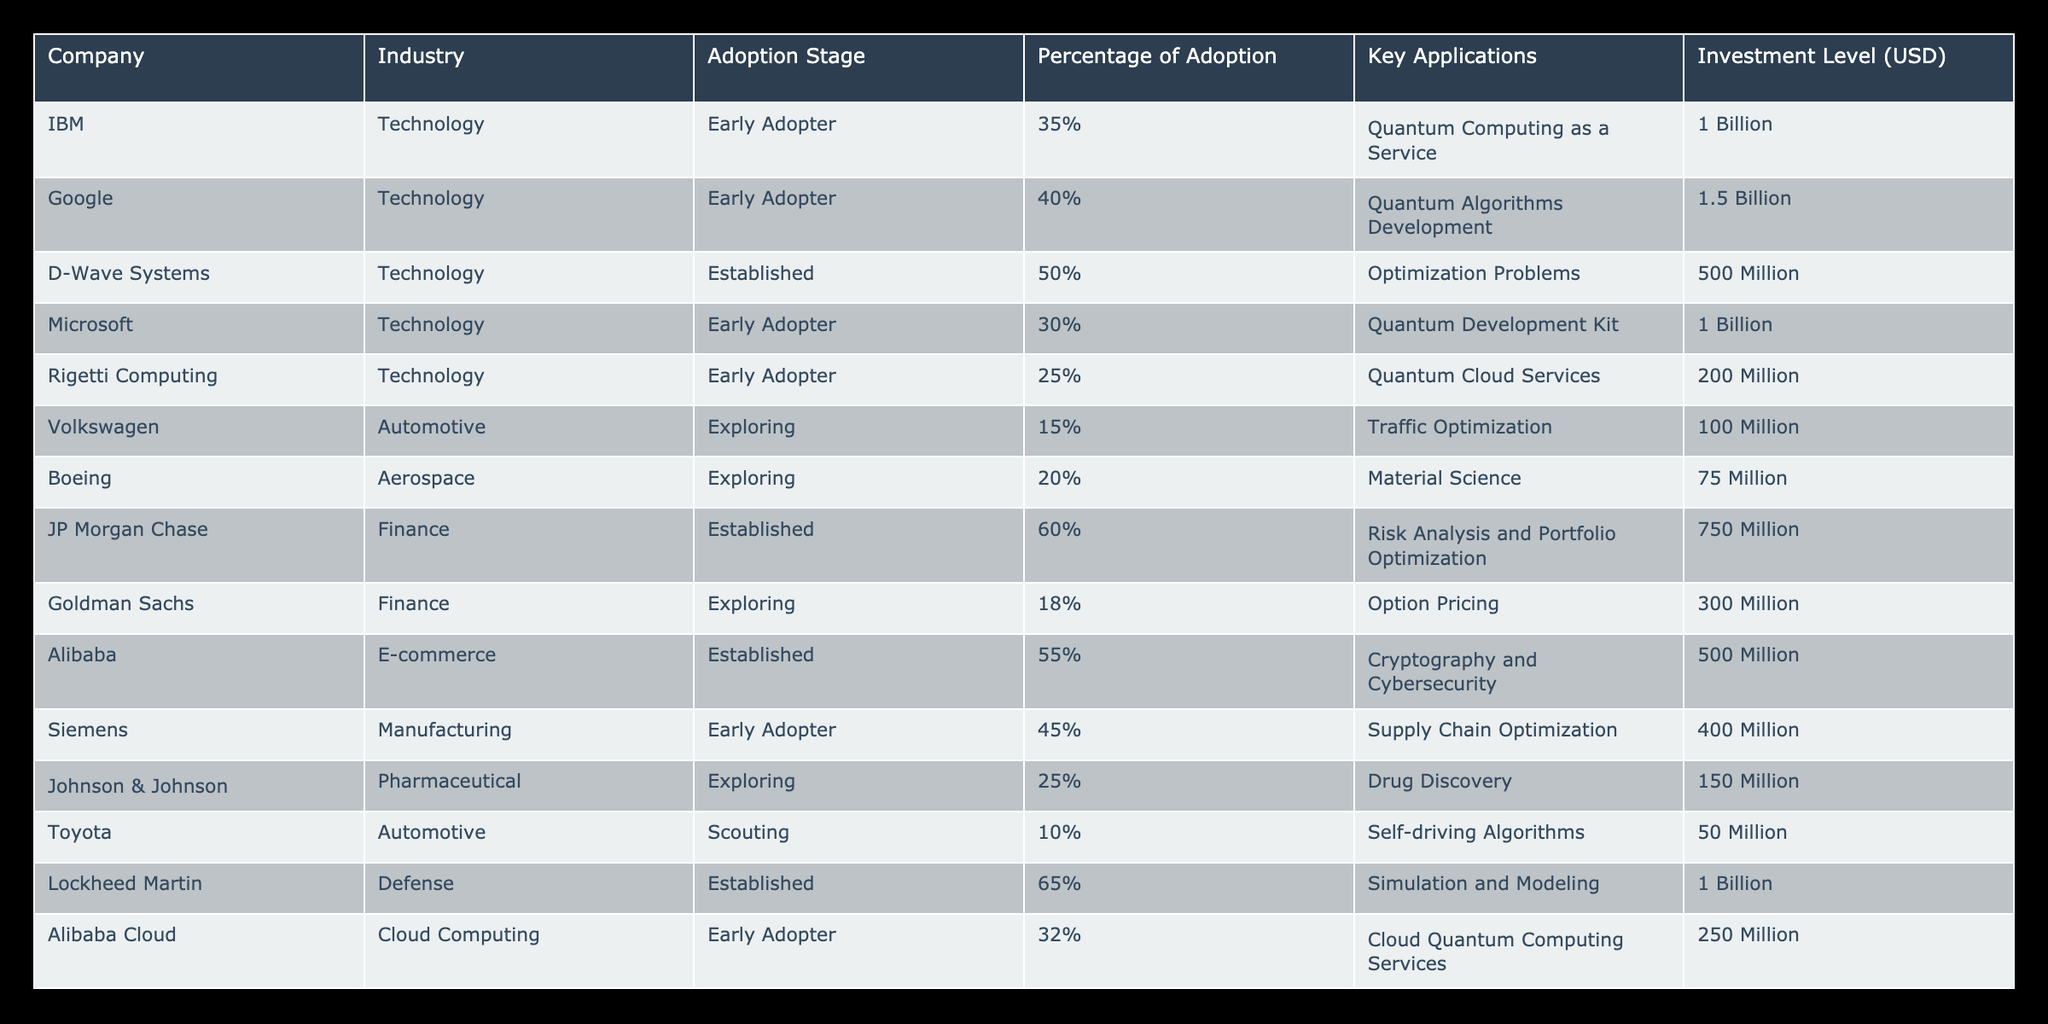What percentage of adoption does JP Morgan Chase have? JP Morgan Chase is listed under the Finance industry in the table, and the corresponding value in the "Percentage of Adoption" column is 60%.
Answer: 60% Which company has the highest investment level in quantum computing technologies? The highest investment level is noted for Lockheed Martin with 1 Billion USD depicted in the "Investment Level (USD)" column.
Answer: Lockheed Martin How many companies are in the Established adoption stage? By counting the rows categorized under the "Established" stage, there are 4 companies: D-Wave Systems, JP Morgan Chase, Alibaba, and Lockheed Martin.
Answer: 4 What is the average percentage of adoption across all companies listed? The total percentage of adoption from all companies is calculated as (35% + 40% + 50% + 30% + 25% + 15% + 20% + 60% + 18% + 55% + 45% + 25% + 10% + 65% + 32%)/15 = 37.67%. Thus, the average percentage is approximately 37.67%.
Answer: Approximately 37.67% Is Volkswagen considered an Established adopter of quantum computing technologies? In the table, Volkswagen is categorized as "Exploring," which indicates they have not reached the Established stage yet.
Answer: No Which industry has the lowest average investment level in quantum computing? The Automotive industry has the lowest investments when comparing the values: 15 Million (Volkswagen), 20 Million (Boeing), and 50 Million (Toyota), averaging at 28.33 Million USD.
Answer: Automotive How does the adoption stage affect investment levels in quantum computing across the companies? Companies in the Established stage have a total investment of (500 Million + 750 Million + 500 Million + 1 Billion) = 2.75 Billion, while Early Adopters have a total of (1 Billion + 1.5 Billion + 1 Billion + 200 Million + 400 Million + 250 Million) = 4.4 Billion, indicating a higher investment for Early Adopters.
Answer: Early Adopters have higher investments What is the total investment level of companies classified as Exploring? The investment levels for the Exploring stage are 100 Million (Volkswagen) + 75 Million (Boeing) + 150 Million (Johnson & Johnson) + 300 Million (Goldman Sachs) = 625 Million USD.
Answer: 625 Million Which company in the pharmaceutical industry is exploring quantum computing technologies? The company in the Pharmaceutical industry listed as Exploring is Johnson & Johnson according to the table.
Answer: Johnson & Johnson 